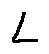<formula> <loc_0><loc_0><loc_500><loc_500>L</formula> 